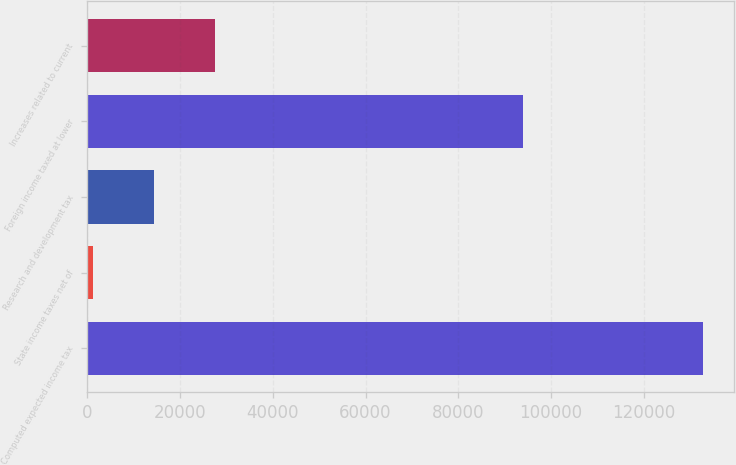Convert chart. <chart><loc_0><loc_0><loc_500><loc_500><bar_chart><fcel>Computed expected income tax<fcel>State income taxes net of<fcel>Research and development tax<fcel>Foreign income taxed at lower<fcel>Increases related to current<nl><fcel>132894<fcel>1280<fcel>14441.4<fcel>93905<fcel>27602.8<nl></chart> 